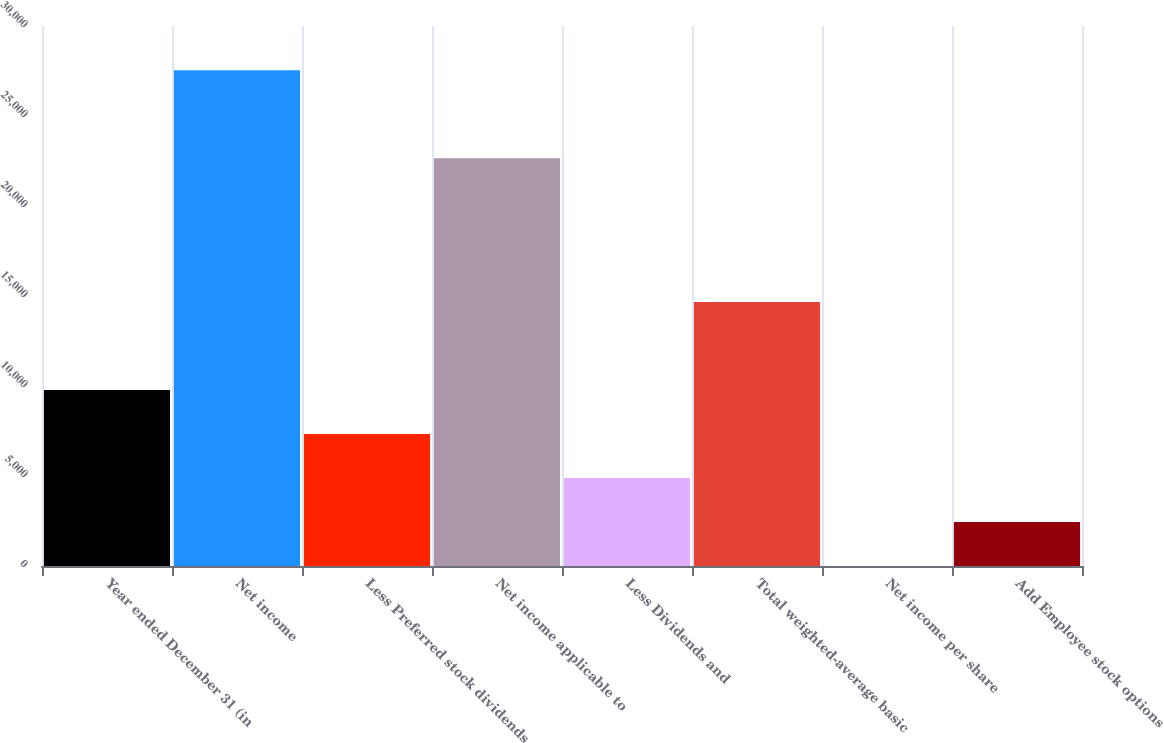Convert chart to OTSL. <chart><loc_0><loc_0><loc_500><loc_500><bar_chart><fcel>Year ended December 31 (in<fcel>Net income<fcel>Less Preferred stock dividends<fcel>Net income applicable to<fcel>Less Dividends and<fcel>Total weighted-average basic<fcel>Net income per share<fcel>Add Employee stock options<nl><fcel>9780.44<fcel>27538.2<fcel>7336.85<fcel>22651<fcel>4893.25<fcel>14667.6<fcel>6.05<fcel>2449.65<nl></chart> 